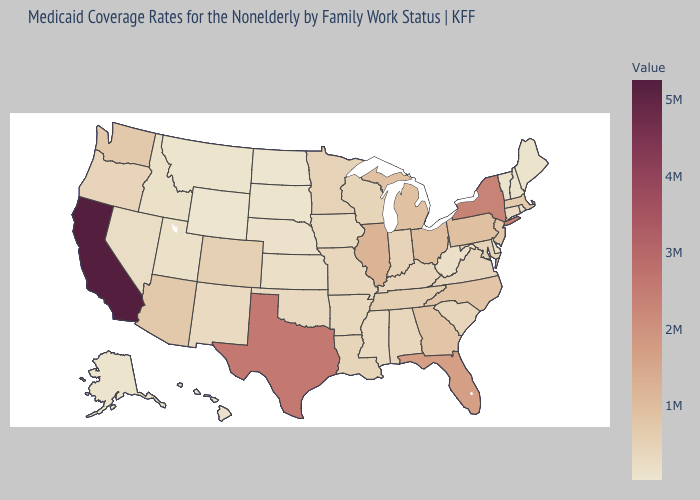Does the map have missing data?
Quick response, please. No. Among the states that border Idaho , does Oregon have the lowest value?
Quick response, please. No. 